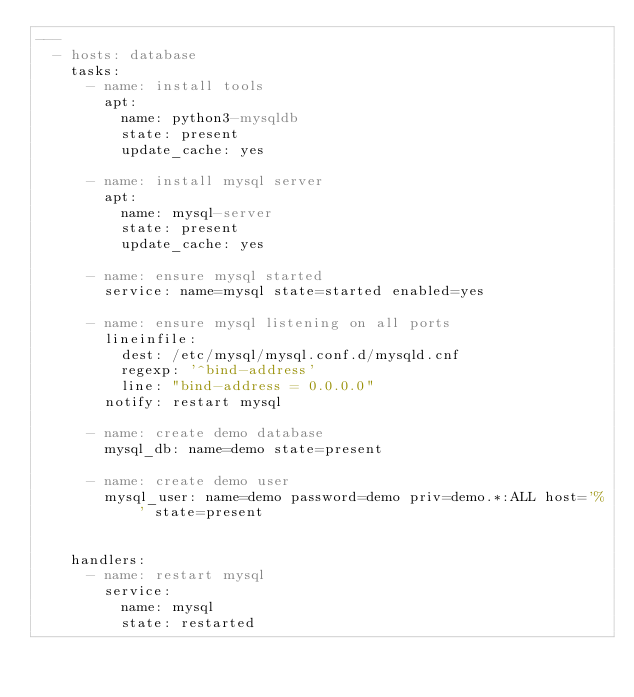<code> <loc_0><loc_0><loc_500><loc_500><_YAML_>---
  - hosts: database
    tasks:
      - name: install tools
        apt:
          name: python3-mysqldb
          state: present
          update_cache: yes

      - name: install mysql server
        apt:
          name: mysql-server
          state: present
          update_cache: yes

      - name: ensure mysql started
        service: name=mysql state=started enabled=yes

      - name: ensure mysql listening on all ports
        lineinfile:
          dest: /etc/mysql/mysql.conf.d/mysqld.cnf
          regexp: '^bind-address'
          line: "bind-address = 0.0.0.0"
        notify: restart mysql

      - name: create demo database
        mysql_db: name=demo state=present

      - name: create demo user
        mysql_user: name=demo password=demo priv=demo.*:ALL host='%' state=present


    handlers:
      - name: restart mysql
        service:
          name: mysql
          state: restarted
</code> 